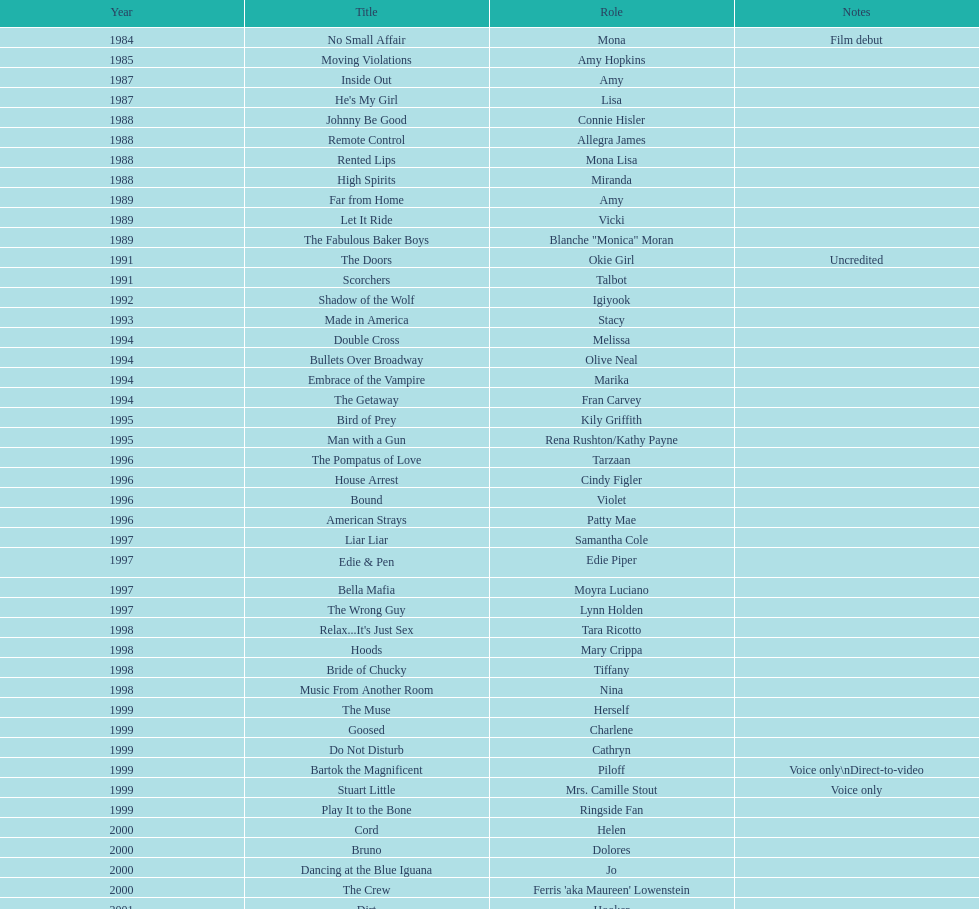How many rolls did jennifer tilly play in the 1980s? 11. 